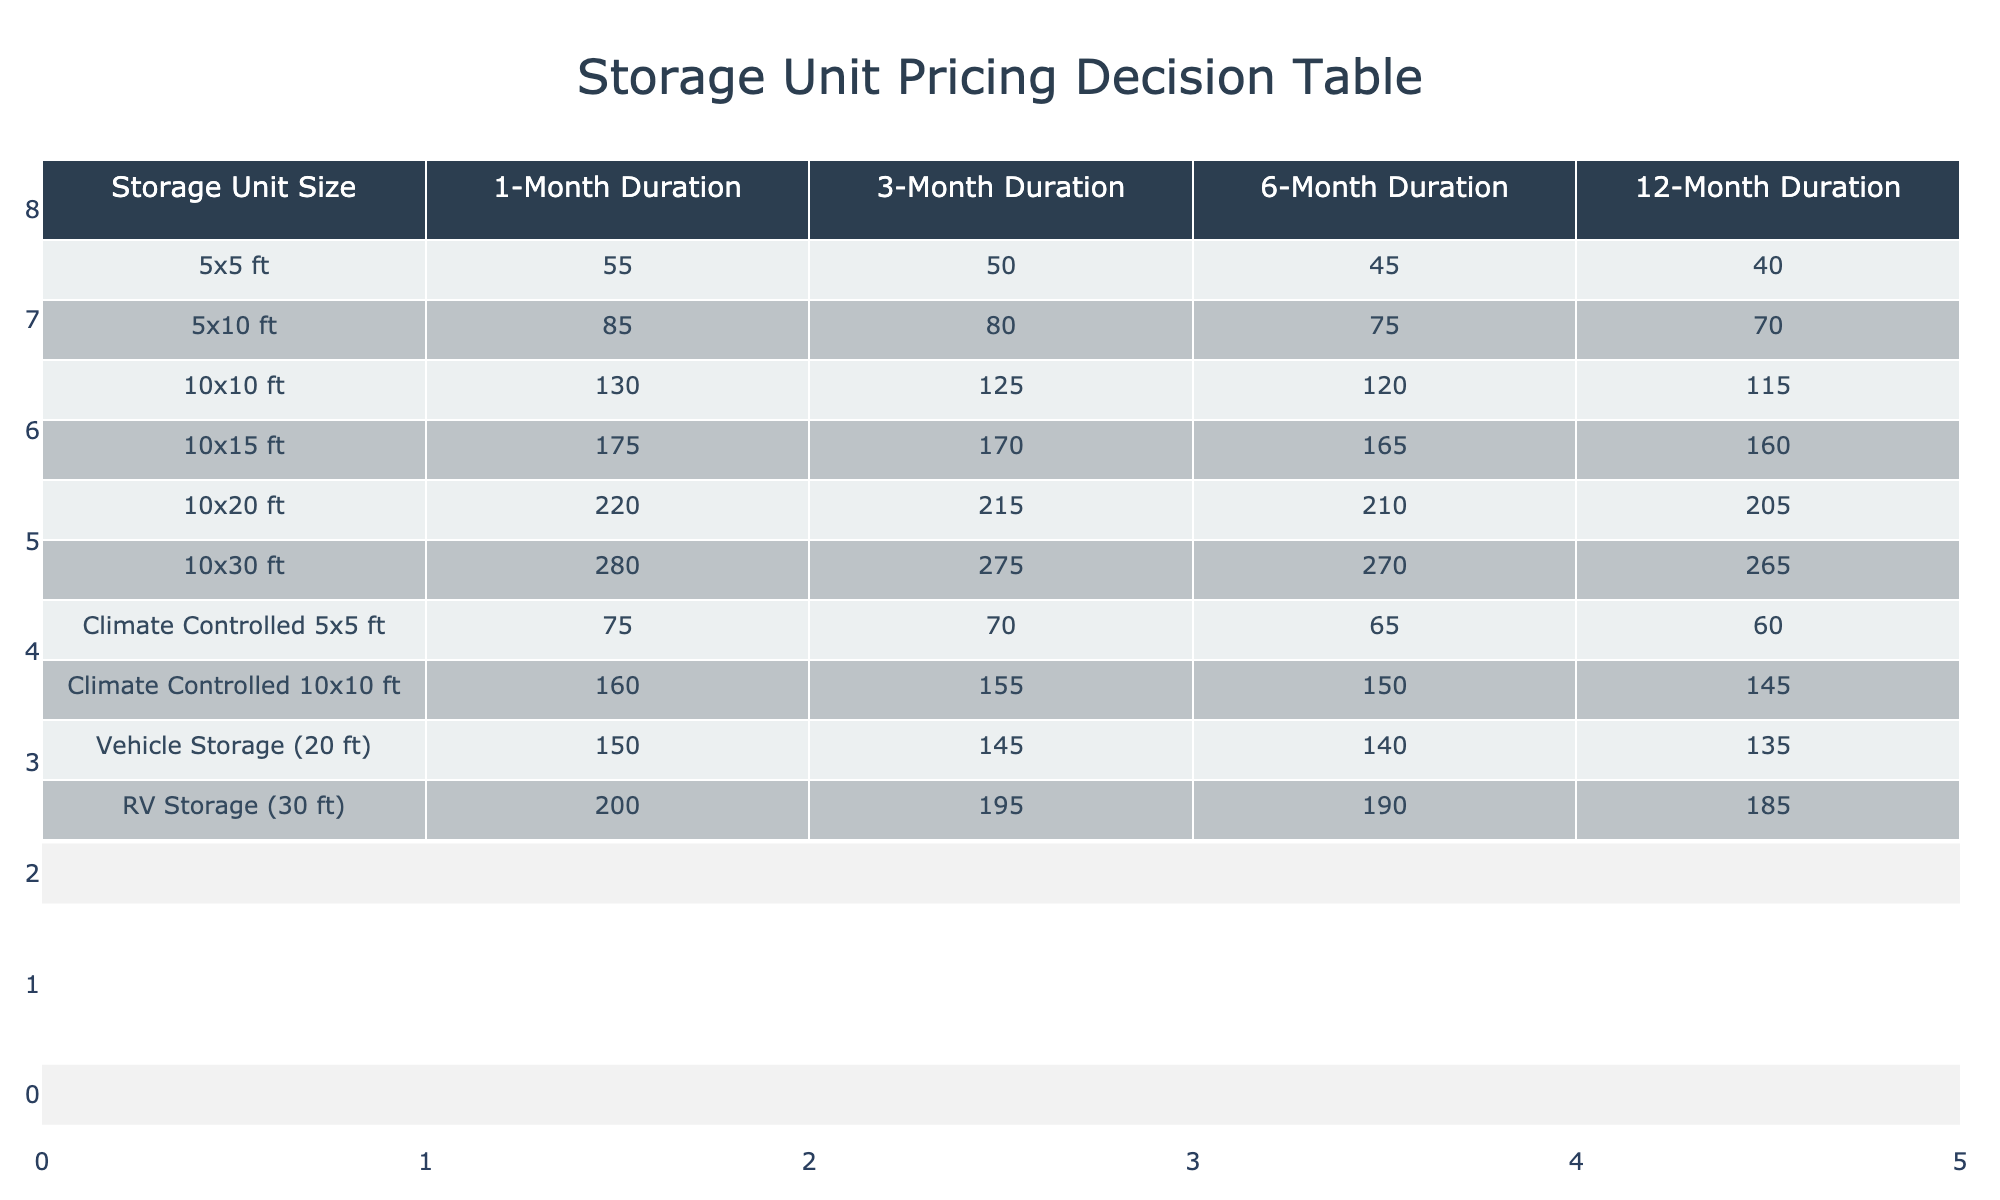What is the price for a 10x20 ft storage unit for a 3-month duration? The table displays the price for various storage unit sizes and durations. For a 10x20 ft storage unit, the 3-month duration price is listed as 215.
Answer: 215 Is climate-controlled storage more expensive than standard storage for the same size unit? To determine whether climate-controlled storage is more expensive than standard storage, we can compare the prices for identical unit sizes. For a 5x5 ft unit, the standard price is 55 while the climate-controlled price is 75. Hence, climate-controlled storage is indeed more expensive.
Answer: Yes What is the total cost for renting a 10x15 ft unit for 6 months and a 5x10 ft unit for 12 months? To find the total cost, we need to retrieve the individual costs. A 10x15 ft unit for 6 months is priced at 165, and a 5x10 ft unit for 12 months is priced at 70. Therefore, the total cost is 165 + 70 = 235.
Answer: 235 How much cheaper is a climate-controlled 10x10 ft unit compared to a standard 10x10 ft unit for a 1-month duration? The climate-controlled 10x10 ft unit costs 160, while the standard unit costs 130. The difference is calculated as 160 - 130 = 30. Thus, the climate-controlled unit is not cheaper but rather more expensive by 30.
Answer: 30 What is the average price for all 1-month duration storage options? To find the average price for all 1-month options, we first gather the prices: 55, 85, 130, 175, 220, 280, 75, 160, 150, and 200. Summing these prices gives us 1,305. There are 10 options, so the average price is 1,305 / 10 = 130.5.
Answer: 130.5 Is the price for a 10x30 ft unit the highest among all units for a 1-month duration? The price for a 10x30 ft unit is 280. We need to compare this against all 1-month prices. The highest recorded price for the other units is also 280 for the 10x30 ft. Thus, it is the highest.
Answer: Yes What is the difference in price for a 5x5 ft unit between a 1-month and a 12-month duration? The price for a 5x5 ft unit for 1 month is 55, and for 12 months, it is 40. The difference is calculated by subtracting the two prices: 55 - 40 = 15.
Answer: 15 How much would it cost to rent a vehicle storage for 6 months? From the table, the vehicle storage (20 ft) for 6 months costs 140. We directly read this price from the table for this specific storage type and duration.
Answer: 140 